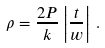<formula> <loc_0><loc_0><loc_500><loc_500>\rho = \frac { 2 P } { k } \left | \frac { t } { w } \right | \, .</formula> 